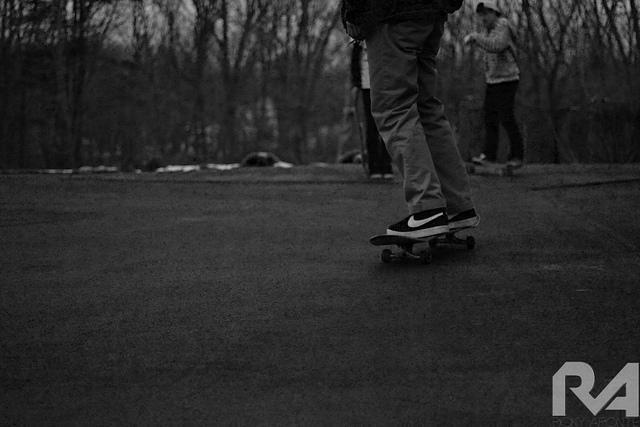How many people are there?
Give a very brief answer. 3. 